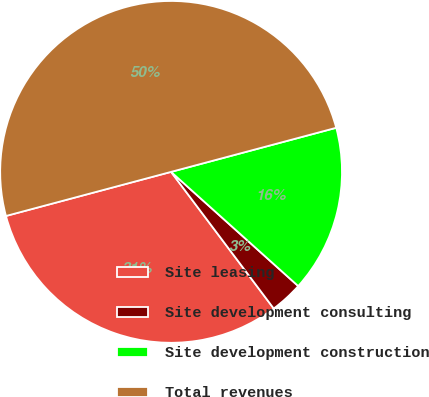Convert chart. <chart><loc_0><loc_0><loc_500><loc_500><pie_chart><fcel>Site leasing<fcel>Site development consulting<fcel>Site development construction<fcel>Total revenues<nl><fcel>31.1%<fcel>3.1%<fcel>15.8%<fcel>50.0%<nl></chart> 